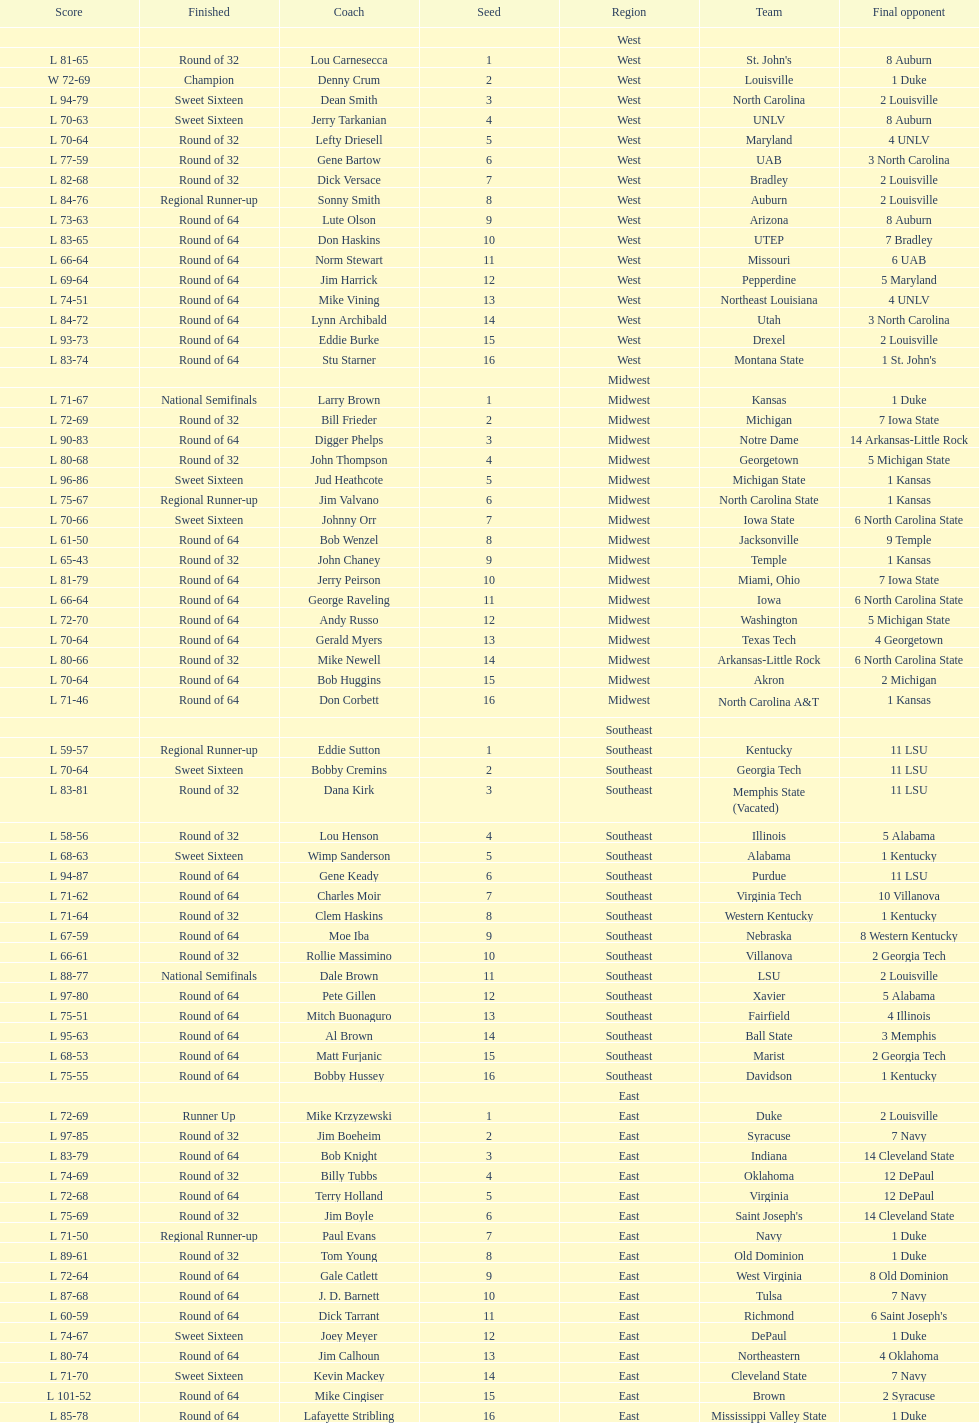What region is listed before the midwest? West. 